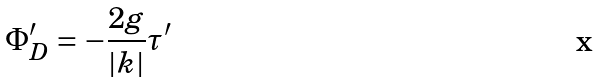Convert formula to latex. <formula><loc_0><loc_0><loc_500><loc_500>\Phi _ { D } ^ { \prime } = - \frac { 2 g } { | k | } \tau ^ { \prime }</formula> 